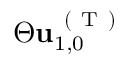<formula> <loc_0><loc_0><loc_500><loc_500>\Theta u _ { 1 , 0 } ^ { ( T ) }</formula> 